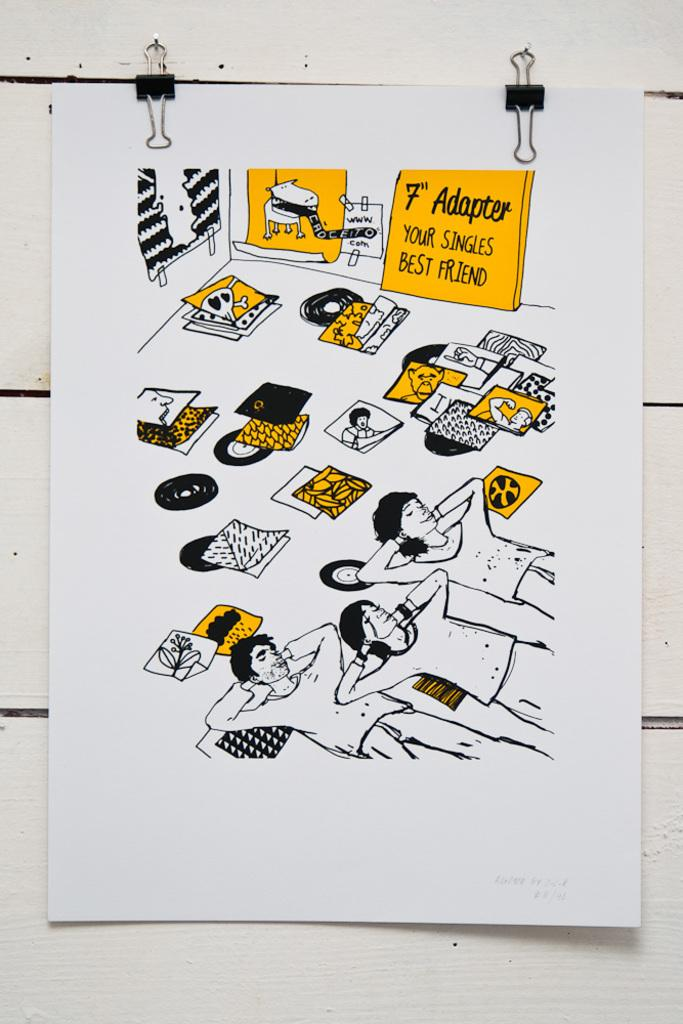<image>
Relay a brief, clear account of the picture shown. A white piece of paper which shows a yellow sign reading 7th Adapter. 